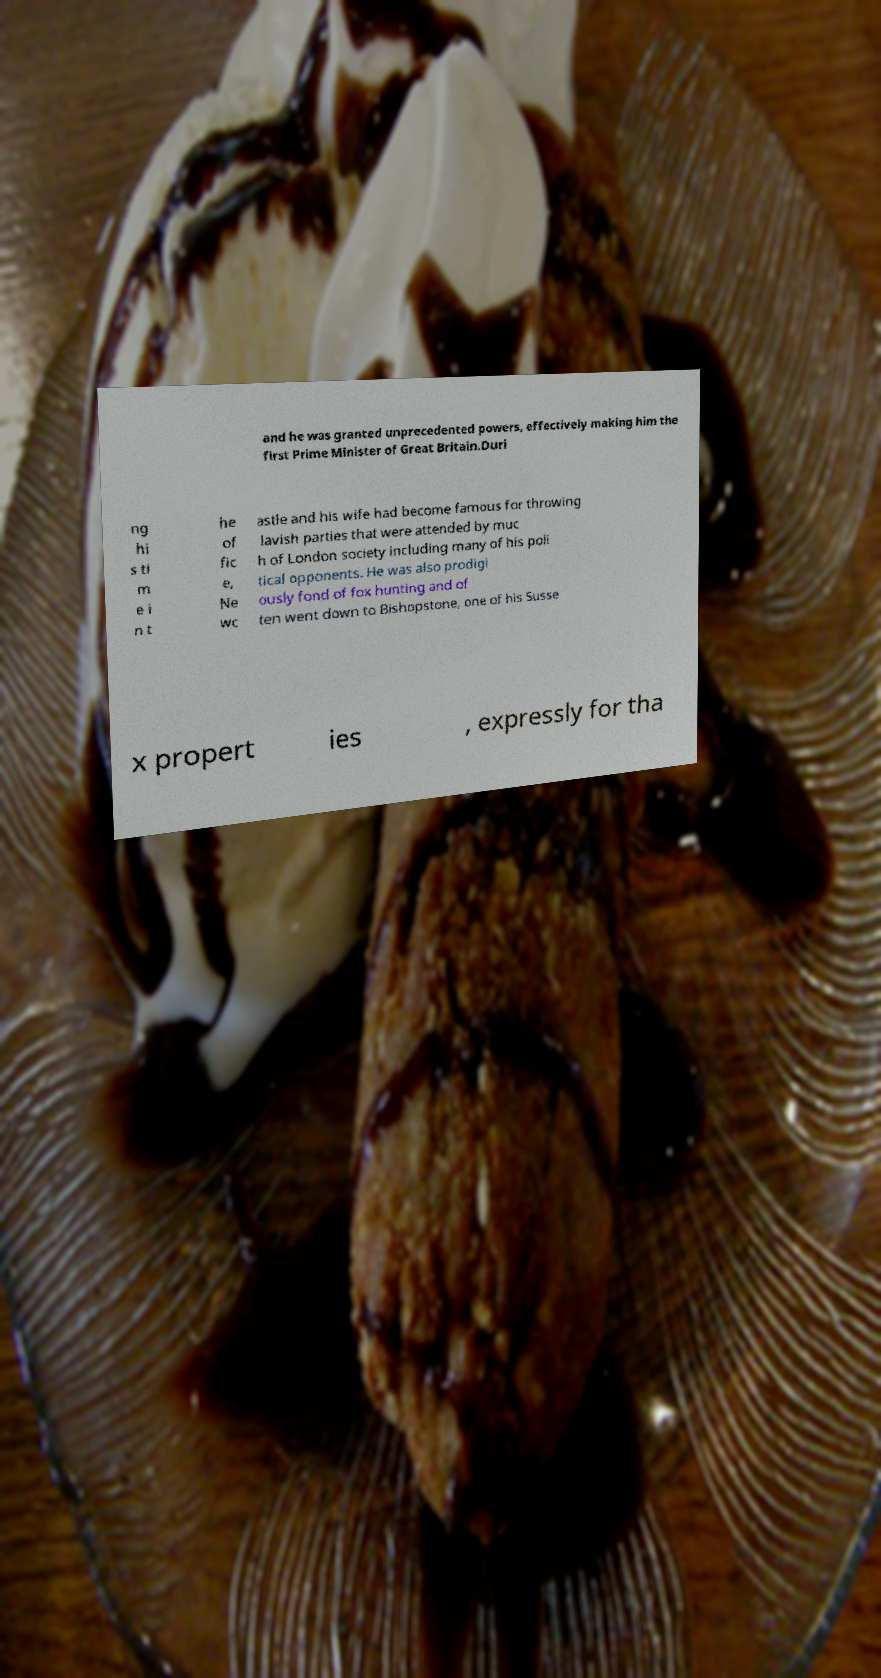Can you accurately transcribe the text from the provided image for me? and he was granted unprecedented powers, effectively making him the first Prime Minister of Great Britain.Duri ng hi s ti m e i n t he of fic e, Ne wc astle and his wife had become famous for throwing lavish parties that were attended by muc h of London society including many of his poli tical opponents. He was also prodigi ously fond of fox hunting and of ten went down to Bishopstone, one of his Susse x propert ies , expressly for tha 